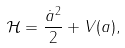<formula> <loc_0><loc_0><loc_500><loc_500>\mathcal { H } = \frac { \dot { a } ^ { 2 } } { 2 } + V ( a ) ,</formula> 